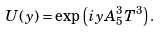<formula> <loc_0><loc_0><loc_500><loc_500>U ( y ) = \exp \left ( i y A _ { 5 } ^ { 3 } T ^ { 3 } \right ) .</formula> 